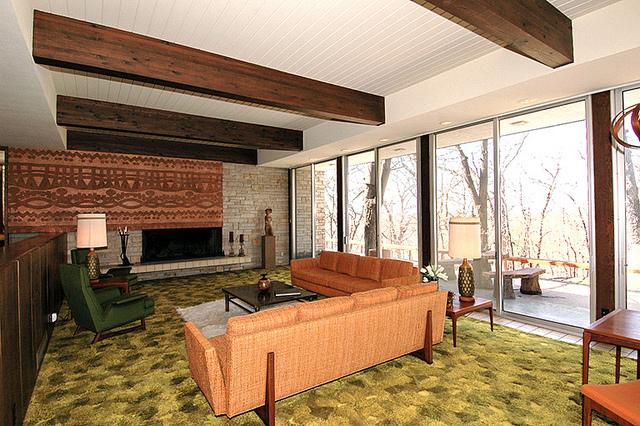Is it night time outside?
Quick response, please. No. What is this room used for?
Answer briefly. Living. What color are the couches?
Write a very short answer. Orange. Is there any sofa in the room?
Give a very brief answer. Yes. 